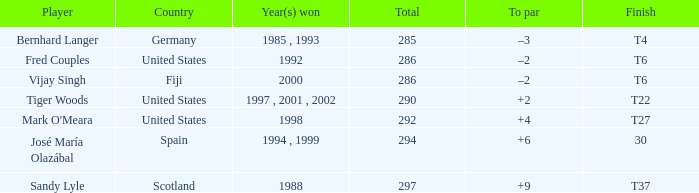Which country has a finish of t22? United States. Can you give me this table as a dict? {'header': ['Player', 'Country', 'Year(s) won', 'Total', 'To par', 'Finish'], 'rows': [['Bernhard Langer', 'Germany', '1985 , 1993', '285', '–3', 'T4'], ['Fred Couples', 'United States', '1992', '286', '–2', 'T6'], ['Vijay Singh', 'Fiji', '2000', '286', '–2', 'T6'], ['Tiger Woods', 'United States', '1997 , 2001 , 2002', '290', '+2', 'T22'], ["Mark O'Meara", 'United States', '1998', '292', '+4', 'T27'], ['José María Olazábal', 'Spain', '1994 , 1999', '294', '+6', '30'], ['Sandy Lyle', 'Scotland', '1988', '297', '+9', 'T37']]} 